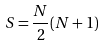<formula> <loc_0><loc_0><loc_500><loc_500>S = \frac { N } { 2 } ( N + 1 )</formula> 